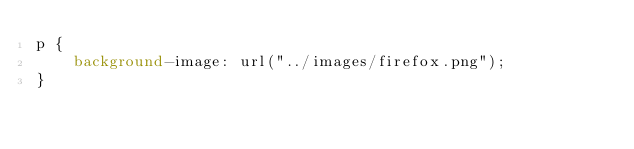Convert code to text. <code><loc_0><loc_0><loc_500><loc_500><_CSS_>p {
    background-image: url("../images/firefox.png");
}</code> 